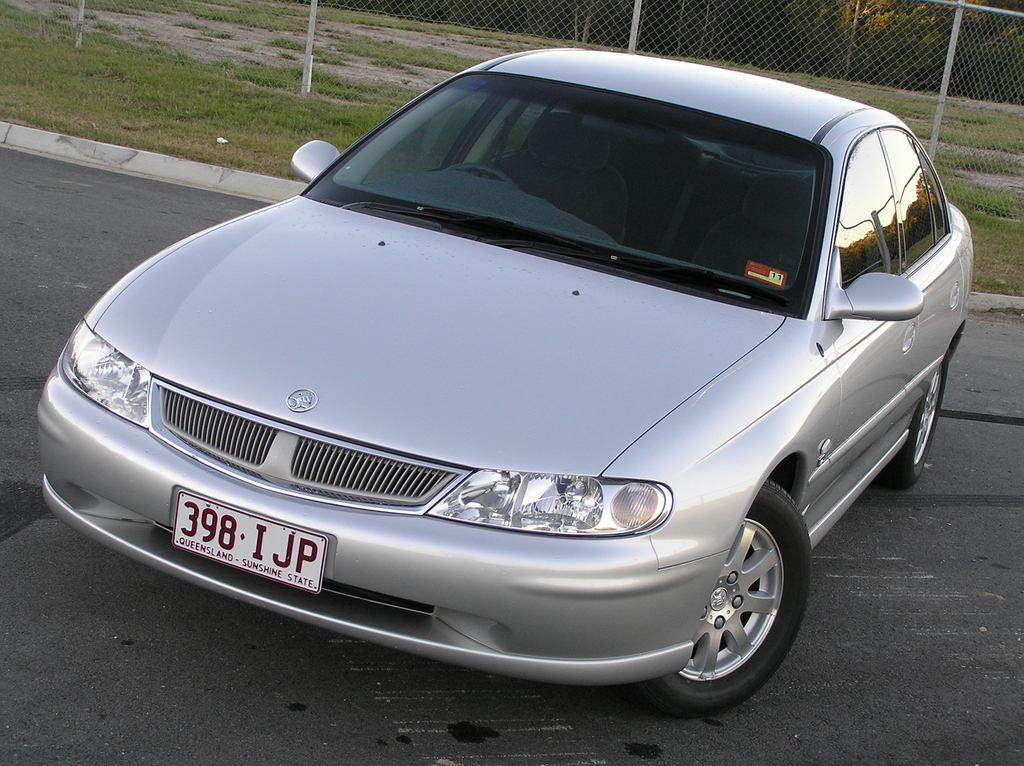Could you give a brief overview of what you see in this image? In this image in the center there is a car. In the background there is grass on the ground and there is a fence. 